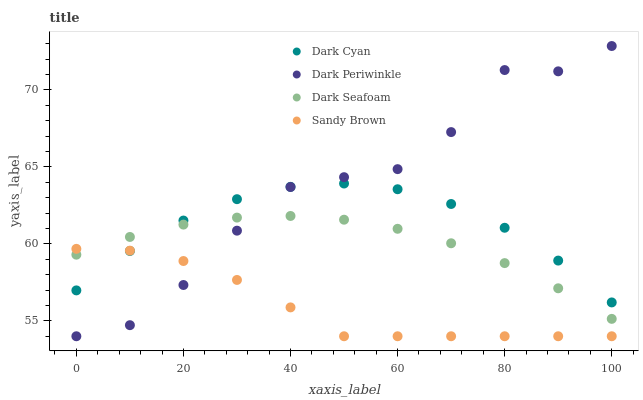Does Sandy Brown have the minimum area under the curve?
Answer yes or no. Yes. Does Dark Periwinkle have the maximum area under the curve?
Answer yes or no. Yes. Does Dark Seafoam have the minimum area under the curve?
Answer yes or no. No. Does Dark Seafoam have the maximum area under the curve?
Answer yes or no. No. Is Dark Seafoam the smoothest?
Answer yes or no. Yes. Is Dark Periwinkle the roughest?
Answer yes or no. Yes. Is Sandy Brown the smoothest?
Answer yes or no. No. Is Sandy Brown the roughest?
Answer yes or no. No. Does Sandy Brown have the lowest value?
Answer yes or no. Yes. Does Dark Seafoam have the lowest value?
Answer yes or no. No. Does Dark Periwinkle have the highest value?
Answer yes or no. Yes. Does Dark Seafoam have the highest value?
Answer yes or no. No. Does Dark Cyan intersect Dark Periwinkle?
Answer yes or no. Yes. Is Dark Cyan less than Dark Periwinkle?
Answer yes or no. No. Is Dark Cyan greater than Dark Periwinkle?
Answer yes or no. No. 